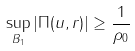<formula> <loc_0><loc_0><loc_500><loc_500>\sup _ { B _ { 1 } } | \Pi ( u , r ) | \geq \frac { 1 } { \rho _ { 0 } }</formula> 